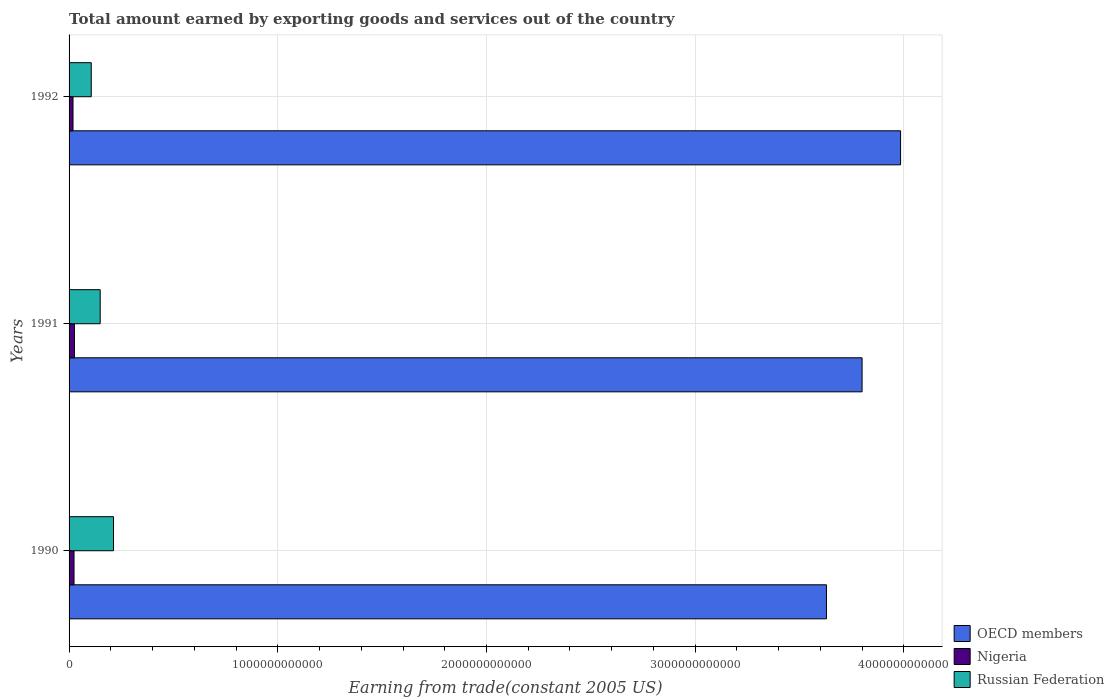How many different coloured bars are there?
Offer a terse response. 3. Are the number of bars per tick equal to the number of legend labels?
Your answer should be very brief. Yes. How many bars are there on the 2nd tick from the top?
Offer a terse response. 3. What is the total amount earned by exporting goods and services in Russian Federation in 1990?
Your answer should be very brief. 2.13e+11. Across all years, what is the maximum total amount earned by exporting goods and services in Nigeria?
Offer a terse response. 2.57e+1. Across all years, what is the minimum total amount earned by exporting goods and services in Nigeria?
Offer a very short reply. 1.89e+1. What is the total total amount earned by exporting goods and services in OECD members in the graph?
Offer a very short reply. 1.14e+13. What is the difference between the total amount earned by exporting goods and services in OECD members in 1990 and that in 1991?
Your answer should be very brief. -1.71e+11. What is the difference between the total amount earned by exporting goods and services in Nigeria in 1990 and the total amount earned by exporting goods and services in Russian Federation in 1992?
Your answer should be compact. -8.25e+1. What is the average total amount earned by exporting goods and services in Nigeria per year?
Ensure brevity in your answer.  2.28e+1. In the year 1990, what is the difference between the total amount earned by exporting goods and services in OECD members and total amount earned by exporting goods and services in Russian Federation?
Keep it short and to the point. 3.42e+12. What is the ratio of the total amount earned by exporting goods and services in OECD members in 1991 to that in 1992?
Keep it short and to the point. 0.95. What is the difference between the highest and the second highest total amount earned by exporting goods and services in OECD members?
Provide a short and direct response. 1.84e+11. What is the difference between the highest and the lowest total amount earned by exporting goods and services in Nigeria?
Offer a very short reply. 6.82e+09. Is the sum of the total amount earned by exporting goods and services in Russian Federation in 1991 and 1992 greater than the maximum total amount earned by exporting goods and services in Nigeria across all years?
Provide a short and direct response. Yes. What does the 1st bar from the top in 1991 represents?
Offer a terse response. Russian Federation. What does the 3rd bar from the bottom in 1991 represents?
Keep it short and to the point. Russian Federation. How many bars are there?
Offer a terse response. 9. What is the difference between two consecutive major ticks on the X-axis?
Offer a terse response. 1.00e+12. How are the legend labels stacked?
Offer a terse response. Vertical. What is the title of the graph?
Give a very brief answer. Total amount earned by exporting goods and services out of the country. What is the label or title of the X-axis?
Ensure brevity in your answer.  Earning from trade(constant 2005 US). What is the label or title of the Y-axis?
Offer a terse response. Years. What is the Earning from trade(constant 2005 US) in OECD members in 1990?
Provide a succinct answer. 3.63e+12. What is the Earning from trade(constant 2005 US) of Nigeria in 1990?
Your response must be concise. 2.38e+1. What is the Earning from trade(constant 2005 US) of Russian Federation in 1990?
Your answer should be compact. 2.13e+11. What is the Earning from trade(constant 2005 US) in OECD members in 1991?
Make the answer very short. 3.80e+12. What is the Earning from trade(constant 2005 US) in Nigeria in 1991?
Make the answer very short. 2.57e+1. What is the Earning from trade(constant 2005 US) of Russian Federation in 1991?
Offer a very short reply. 1.49e+11. What is the Earning from trade(constant 2005 US) in OECD members in 1992?
Your response must be concise. 3.98e+12. What is the Earning from trade(constant 2005 US) in Nigeria in 1992?
Offer a very short reply. 1.89e+1. What is the Earning from trade(constant 2005 US) in Russian Federation in 1992?
Provide a short and direct response. 1.06e+11. Across all years, what is the maximum Earning from trade(constant 2005 US) in OECD members?
Ensure brevity in your answer.  3.98e+12. Across all years, what is the maximum Earning from trade(constant 2005 US) in Nigeria?
Offer a very short reply. 2.57e+1. Across all years, what is the maximum Earning from trade(constant 2005 US) of Russian Federation?
Provide a short and direct response. 2.13e+11. Across all years, what is the minimum Earning from trade(constant 2005 US) in OECD members?
Offer a terse response. 3.63e+12. Across all years, what is the minimum Earning from trade(constant 2005 US) of Nigeria?
Offer a very short reply. 1.89e+1. Across all years, what is the minimum Earning from trade(constant 2005 US) in Russian Federation?
Your answer should be very brief. 1.06e+11. What is the total Earning from trade(constant 2005 US) of OECD members in the graph?
Provide a short and direct response. 1.14e+13. What is the total Earning from trade(constant 2005 US) in Nigeria in the graph?
Ensure brevity in your answer.  6.84e+1. What is the total Earning from trade(constant 2005 US) of Russian Federation in the graph?
Offer a very short reply. 4.68e+11. What is the difference between the Earning from trade(constant 2005 US) in OECD members in 1990 and that in 1991?
Keep it short and to the point. -1.71e+11. What is the difference between the Earning from trade(constant 2005 US) of Nigeria in 1990 and that in 1991?
Offer a terse response. -1.92e+09. What is the difference between the Earning from trade(constant 2005 US) in Russian Federation in 1990 and that in 1991?
Provide a succinct answer. 6.38e+1. What is the difference between the Earning from trade(constant 2005 US) in OECD members in 1990 and that in 1992?
Provide a short and direct response. -3.55e+11. What is the difference between the Earning from trade(constant 2005 US) in Nigeria in 1990 and that in 1992?
Offer a terse response. 4.90e+09. What is the difference between the Earning from trade(constant 2005 US) in Russian Federation in 1990 and that in 1992?
Your answer should be very brief. 1.07e+11. What is the difference between the Earning from trade(constant 2005 US) of OECD members in 1991 and that in 1992?
Offer a terse response. -1.84e+11. What is the difference between the Earning from trade(constant 2005 US) of Nigeria in 1991 and that in 1992?
Your response must be concise. 6.82e+09. What is the difference between the Earning from trade(constant 2005 US) of Russian Federation in 1991 and that in 1992?
Provide a succinct answer. 4.28e+1. What is the difference between the Earning from trade(constant 2005 US) in OECD members in 1990 and the Earning from trade(constant 2005 US) in Nigeria in 1991?
Offer a very short reply. 3.60e+12. What is the difference between the Earning from trade(constant 2005 US) in OECD members in 1990 and the Earning from trade(constant 2005 US) in Russian Federation in 1991?
Make the answer very short. 3.48e+12. What is the difference between the Earning from trade(constant 2005 US) of Nigeria in 1990 and the Earning from trade(constant 2005 US) of Russian Federation in 1991?
Provide a succinct answer. -1.25e+11. What is the difference between the Earning from trade(constant 2005 US) in OECD members in 1990 and the Earning from trade(constant 2005 US) in Nigeria in 1992?
Your answer should be very brief. 3.61e+12. What is the difference between the Earning from trade(constant 2005 US) in OECD members in 1990 and the Earning from trade(constant 2005 US) in Russian Federation in 1992?
Your response must be concise. 3.52e+12. What is the difference between the Earning from trade(constant 2005 US) in Nigeria in 1990 and the Earning from trade(constant 2005 US) in Russian Federation in 1992?
Give a very brief answer. -8.25e+1. What is the difference between the Earning from trade(constant 2005 US) of OECD members in 1991 and the Earning from trade(constant 2005 US) of Nigeria in 1992?
Give a very brief answer. 3.78e+12. What is the difference between the Earning from trade(constant 2005 US) in OECD members in 1991 and the Earning from trade(constant 2005 US) in Russian Federation in 1992?
Provide a succinct answer. 3.69e+12. What is the difference between the Earning from trade(constant 2005 US) of Nigeria in 1991 and the Earning from trade(constant 2005 US) of Russian Federation in 1992?
Keep it short and to the point. -8.06e+1. What is the average Earning from trade(constant 2005 US) in OECD members per year?
Ensure brevity in your answer.  3.80e+12. What is the average Earning from trade(constant 2005 US) of Nigeria per year?
Offer a very short reply. 2.28e+1. What is the average Earning from trade(constant 2005 US) in Russian Federation per year?
Ensure brevity in your answer.  1.56e+11. In the year 1990, what is the difference between the Earning from trade(constant 2005 US) in OECD members and Earning from trade(constant 2005 US) in Nigeria?
Provide a short and direct response. 3.61e+12. In the year 1990, what is the difference between the Earning from trade(constant 2005 US) in OECD members and Earning from trade(constant 2005 US) in Russian Federation?
Ensure brevity in your answer.  3.42e+12. In the year 1990, what is the difference between the Earning from trade(constant 2005 US) of Nigeria and Earning from trade(constant 2005 US) of Russian Federation?
Keep it short and to the point. -1.89e+11. In the year 1991, what is the difference between the Earning from trade(constant 2005 US) of OECD members and Earning from trade(constant 2005 US) of Nigeria?
Your response must be concise. 3.77e+12. In the year 1991, what is the difference between the Earning from trade(constant 2005 US) in OECD members and Earning from trade(constant 2005 US) in Russian Federation?
Provide a succinct answer. 3.65e+12. In the year 1991, what is the difference between the Earning from trade(constant 2005 US) in Nigeria and Earning from trade(constant 2005 US) in Russian Federation?
Your answer should be very brief. -1.23e+11. In the year 1992, what is the difference between the Earning from trade(constant 2005 US) of OECD members and Earning from trade(constant 2005 US) of Nigeria?
Provide a succinct answer. 3.97e+12. In the year 1992, what is the difference between the Earning from trade(constant 2005 US) in OECD members and Earning from trade(constant 2005 US) in Russian Federation?
Give a very brief answer. 3.88e+12. In the year 1992, what is the difference between the Earning from trade(constant 2005 US) in Nigeria and Earning from trade(constant 2005 US) in Russian Federation?
Your response must be concise. -8.74e+1. What is the ratio of the Earning from trade(constant 2005 US) in OECD members in 1990 to that in 1991?
Your answer should be compact. 0.96. What is the ratio of the Earning from trade(constant 2005 US) of Nigeria in 1990 to that in 1991?
Your response must be concise. 0.93. What is the ratio of the Earning from trade(constant 2005 US) in Russian Federation in 1990 to that in 1991?
Your answer should be compact. 1.43. What is the ratio of the Earning from trade(constant 2005 US) of OECD members in 1990 to that in 1992?
Keep it short and to the point. 0.91. What is the ratio of the Earning from trade(constant 2005 US) of Nigeria in 1990 to that in 1992?
Your answer should be very brief. 1.26. What is the ratio of the Earning from trade(constant 2005 US) in Russian Federation in 1990 to that in 1992?
Make the answer very short. 2. What is the ratio of the Earning from trade(constant 2005 US) of OECD members in 1991 to that in 1992?
Offer a very short reply. 0.95. What is the ratio of the Earning from trade(constant 2005 US) in Nigeria in 1991 to that in 1992?
Offer a very short reply. 1.36. What is the ratio of the Earning from trade(constant 2005 US) in Russian Federation in 1991 to that in 1992?
Offer a terse response. 1.4. What is the difference between the highest and the second highest Earning from trade(constant 2005 US) in OECD members?
Give a very brief answer. 1.84e+11. What is the difference between the highest and the second highest Earning from trade(constant 2005 US) of Nigeria?
Provide a succinct answer. 1.92e+09. What is the difference between the highest and the second highest Earning from trade(constant 2005 US) of Russian Federation?
Offer a terse response. 6.38e+1. What is the difference between the highest and the lowest Earning from trade(constant 2005 US) of OECD members?
Offer a terse response. 3.55e+11. What is the difference between the highest and the lowest Earning from trade(constant 2005 US) in Nigeria?
Ensure brevity in your answer.  6.82e+09. What is the difference between the highest and the lowest Earning from trade(constant 2005 US) in Russian Federation?
Offer a terse response. 1.07e+11. 